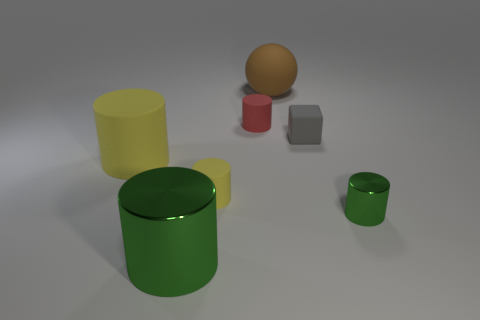Do the large thing to the left of the large green cylinder and the small red cylinder have the same material?
Offer a terse response. Yes. There is a green object that is to the right of the green metal object that is to the left of the small gray matte thing; what is it made of?
Provide a succinct answer. Metal. What number of yellow matte objects have the same shape as the tiny red object?
Ensure brevity in your answer.  2. There is a yellow thing in front of the yellow matte cylinder that is behind the matte cylinder that is in front of the big matte cylinder; what is its size?
Provide a short and direct response. Small. How many green things are either matte objects or cylinders?
Make the answer very short. 2. There is a shiny thing right of the gray cube; is its shape the same as the tiny gray rubber thing?
Your answer should be compact. No. Are there more large rubber things that are in front of the brown matte ball than big blue cubes?
Ensure brevity in your answer.  Yes. How many green cylinders have the same size as the brown object?
Provide a succinct answer. 1. There is a shiny thing that is the same color as the tiny metal cylinder; what is its size?
Your answer should be very brief. Large. What number of objects are either gray blocks or rubber objects that are to the right of the large brown rubber ball?
Make the answer very short. 1. 